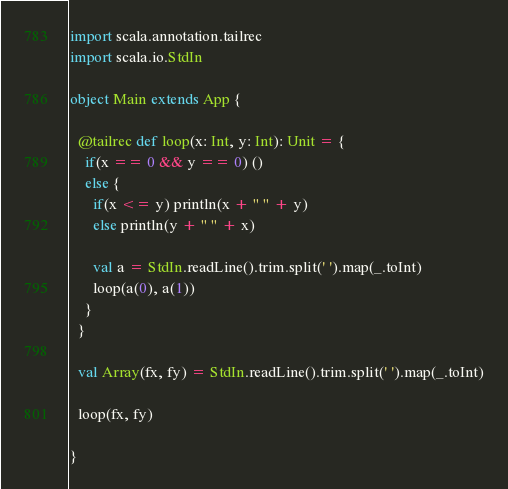<code> <loc_0><loc_0><loc_500><loc_500><_Scala_>import scala.annotation.tailrec
import scala.io.StdIn

object Main extends App {
  
  @tailrec def loop(x: Int, y: Int): Unit = {
    if(x == 0 && y == 0) ()
    else {
      if(x <= y) println(x + " " + y)
      else println(y + " " + x)

      val a = StdIn.readLine().trim.split(' ').map(_.toInt)
      loop(a(0), a(1))
    } 
  }

  val Array(fx, fy) = StdIn.readLine().trim.split(' ').map(_.toInt)

  loop(fx, fy)

}
</code> 